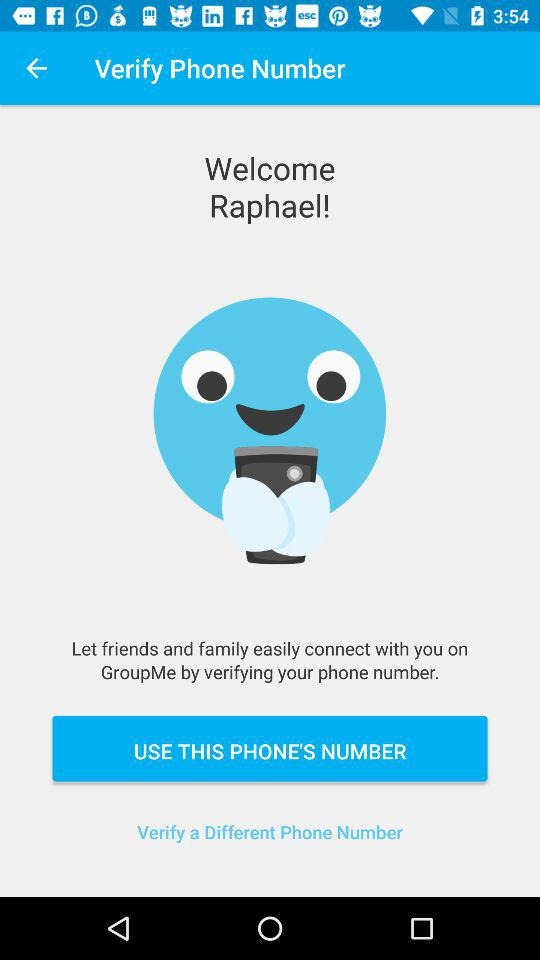What is the name of the application? The name of the application is "Verify Phone Number". 